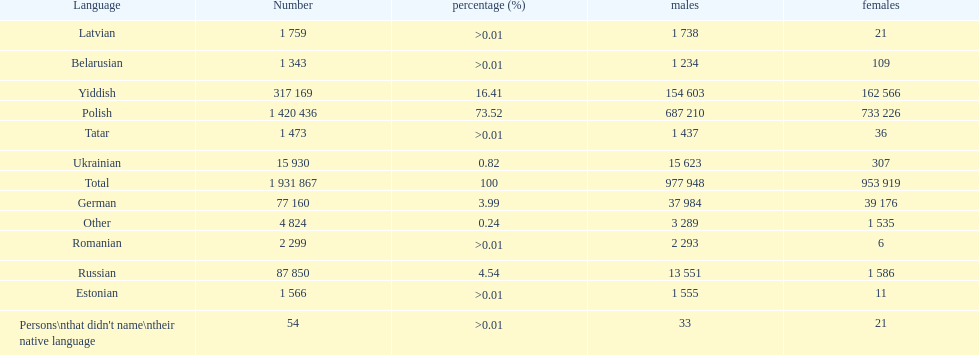The least amount of females Romanian. Can you give me this table as a dict? {'header': ['Language', 'Number', 'percentage (%)', 'males', 'females'], 'rows': [['Latvian', '1 759', '>0.01', '1 738', '21'], ['Belarusian', '1 343', '>0.01', '1 234', '109'], ['Yiddish', '317 169', '16.41', '154 603', '162 566'], ['Polish', '1 420 436', '73.52', '687 210', '733 226'], ['Tatar', '1 473', '>0.01', '1 437', '36'], ['Ukrainian', '15 930', '0.82', '15 623', '307'], ['Total', '1 931 867', '100', '977 948', '953 919'], ['German', '77 160', '3.99', '37 984', '39 176'], ['Other', '4 824', '0.24', '3 289', '1 535'], ['Romanian', '2 299', '>0.01', '2 293', '6'], ['Russian', '87 850', '4.54', '13 551', '1 586'], ['Estonian', '1 566', '>0.01', '1 555', '11'], ["Persons\\nthat didn't name\\ntheir native language", '54', '>0.01', '33', '21']]} 